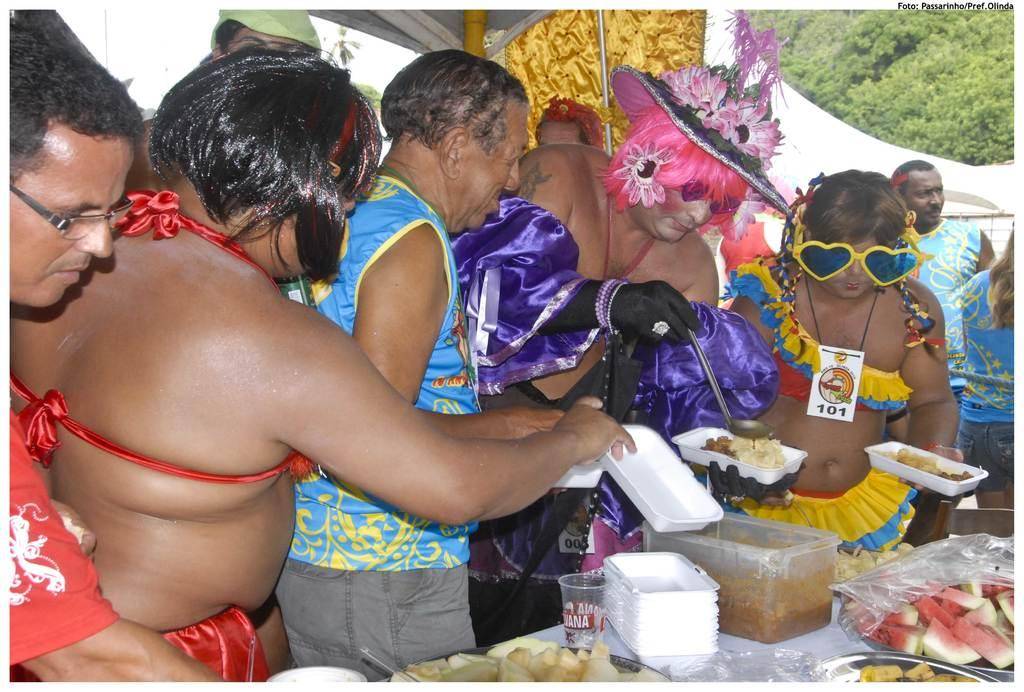How many people are in the image? There are many persons in the image. What are the persons doing in the image? The persons are having food. What are the persons wearing in the image? The persons are wearing costumes. What is located at the bottom of the image? There is a table at the bottom of the image. What can be found on the table in the image? There are many things kept on the table. What can be seen in the background of the image? There are trees visible to the right top of the image. What type of railway can be seen in the image? There is no railway present in the image. What color is the ghost in the image? There is no ghost present in the image. 